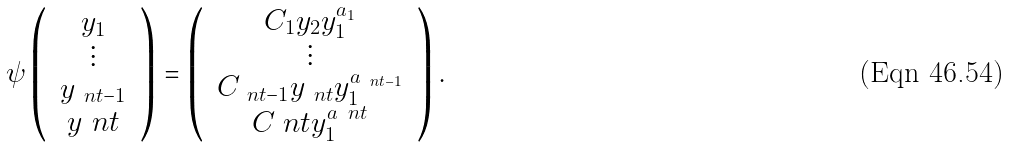<formula> <loc_0><loc_0><loc_500><loc_500>\psi \left ( \, \begin{array} { c } y _ { 1 } \\ \vdots \\ y _ { \ n t - 1 } \\ y _ { \ } n t \\ \end{array} \, \right ) = \left ( \, \begin{array} { c } C _ { 1 } y _ { 2 } y _ { 1 } ^ { a _ { 1 } } \\ \vdots \\ C _ { \ n t - 1 } y _ { \ n t } y _ { 1 } ^ { a _ { \ n t - 1 } } \\ C _ { \ } n t y _ { 1 } ^ { a _ { \ } n t } \end{array} \, \right ) .</formula> 